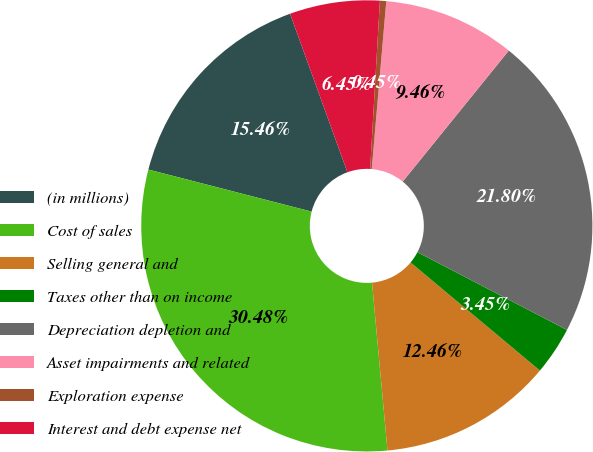<chart> <loc_0><loc_0><loc_500><loc_500><pie_chart><fcel>(in millions)<fcel>Cost of sales<fcel>Selling general and<fcel>Taxes other than on income<fcel>Depreciation depletion and<fcel>Asset impairments and related<fcel>Exploration expense<fcel>Interest and debt expense net<nl><fcel>15.46%<fcel>30.48%<fcel>12.46%<fcel>3.45%<fcel>21.8%<fcel>9.46%<fcel>0.45%<fcel>6.45%<nl></chart> 